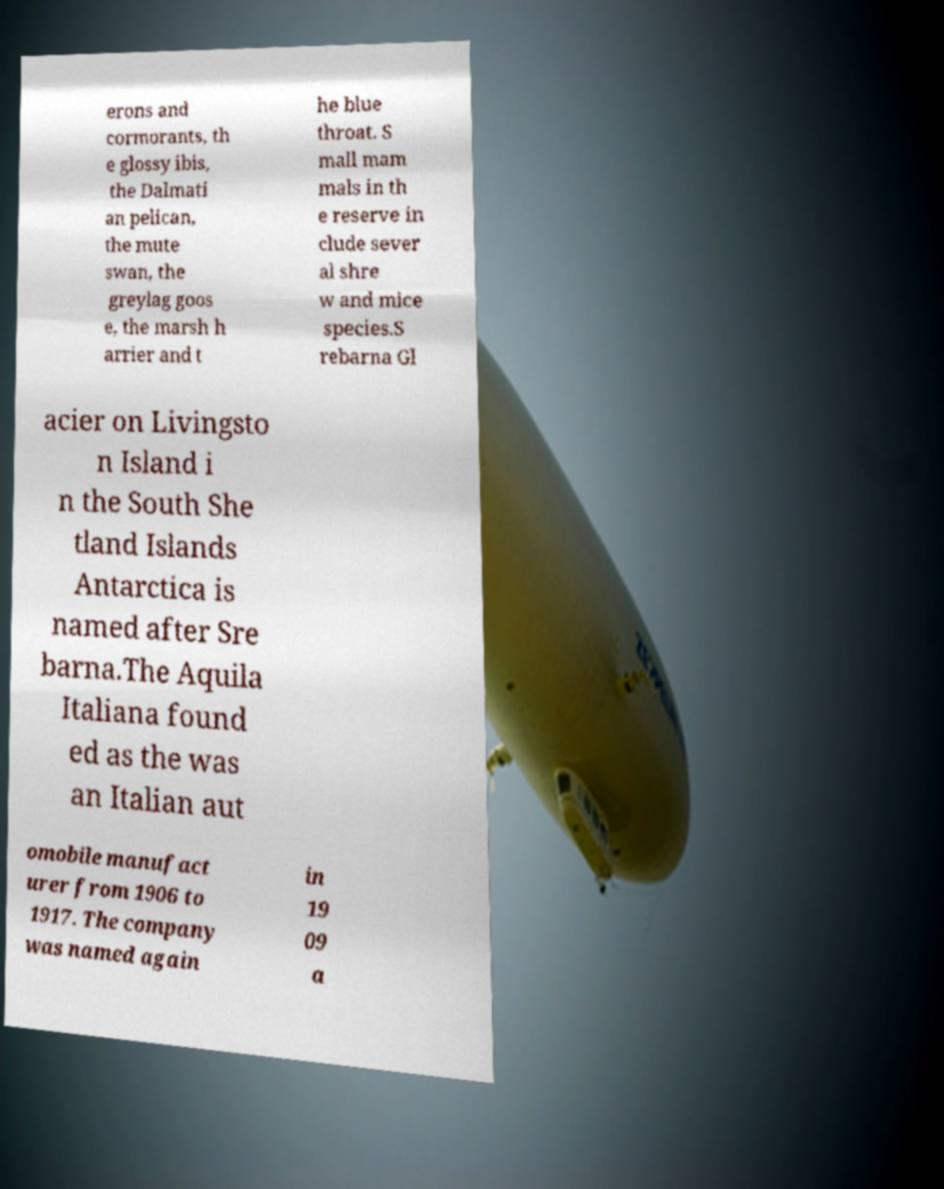Can you read and provide the text displayed in the image?This photo seems to have some interesting text. Can you extract and type it out for me? erons and cormorants, th e glossy ibis, the Dalmati an pelican, the mute swan, the greylag goos e, the marsh h arrier and t he blue throat. S mall mam mals in th e reserve in clude sever al shre w and mice species.S rebarna Gl acier on Livingsto n Island i n the South She tland Islands Antarctica is named after Sre barna.The Aquila Italiana found ed as the was an Italian aut omobile manufact urer from 1906 to 1917. The company was named again in 19 09 a 